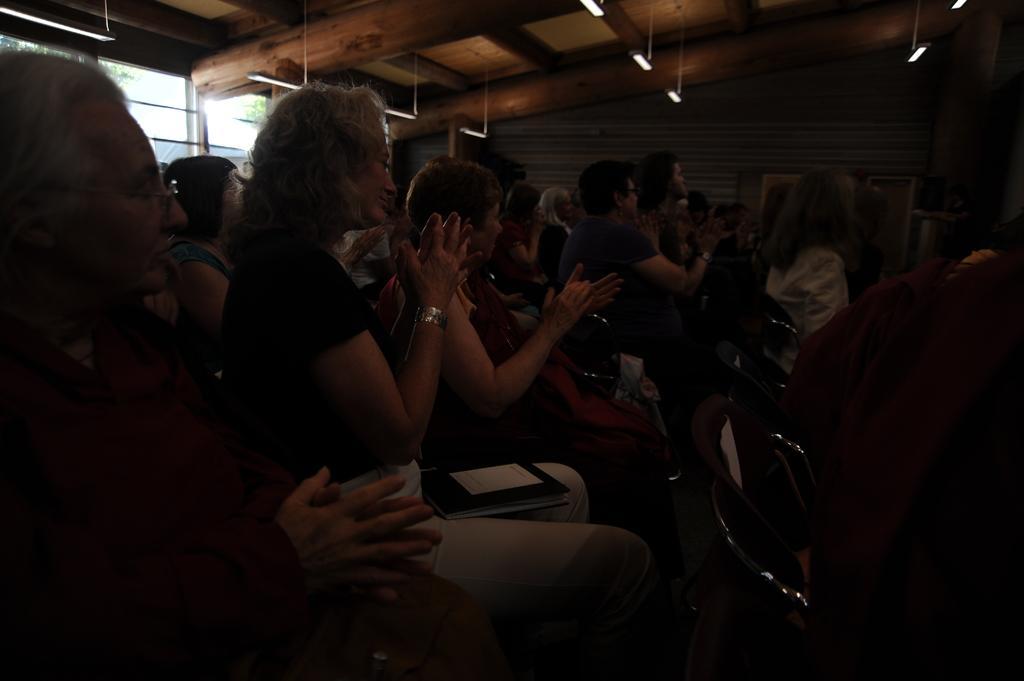How would you summarize this image in a sentence or two? In the left side few women are sitting on the chairs and clapping their hands. At the top there are lights. 